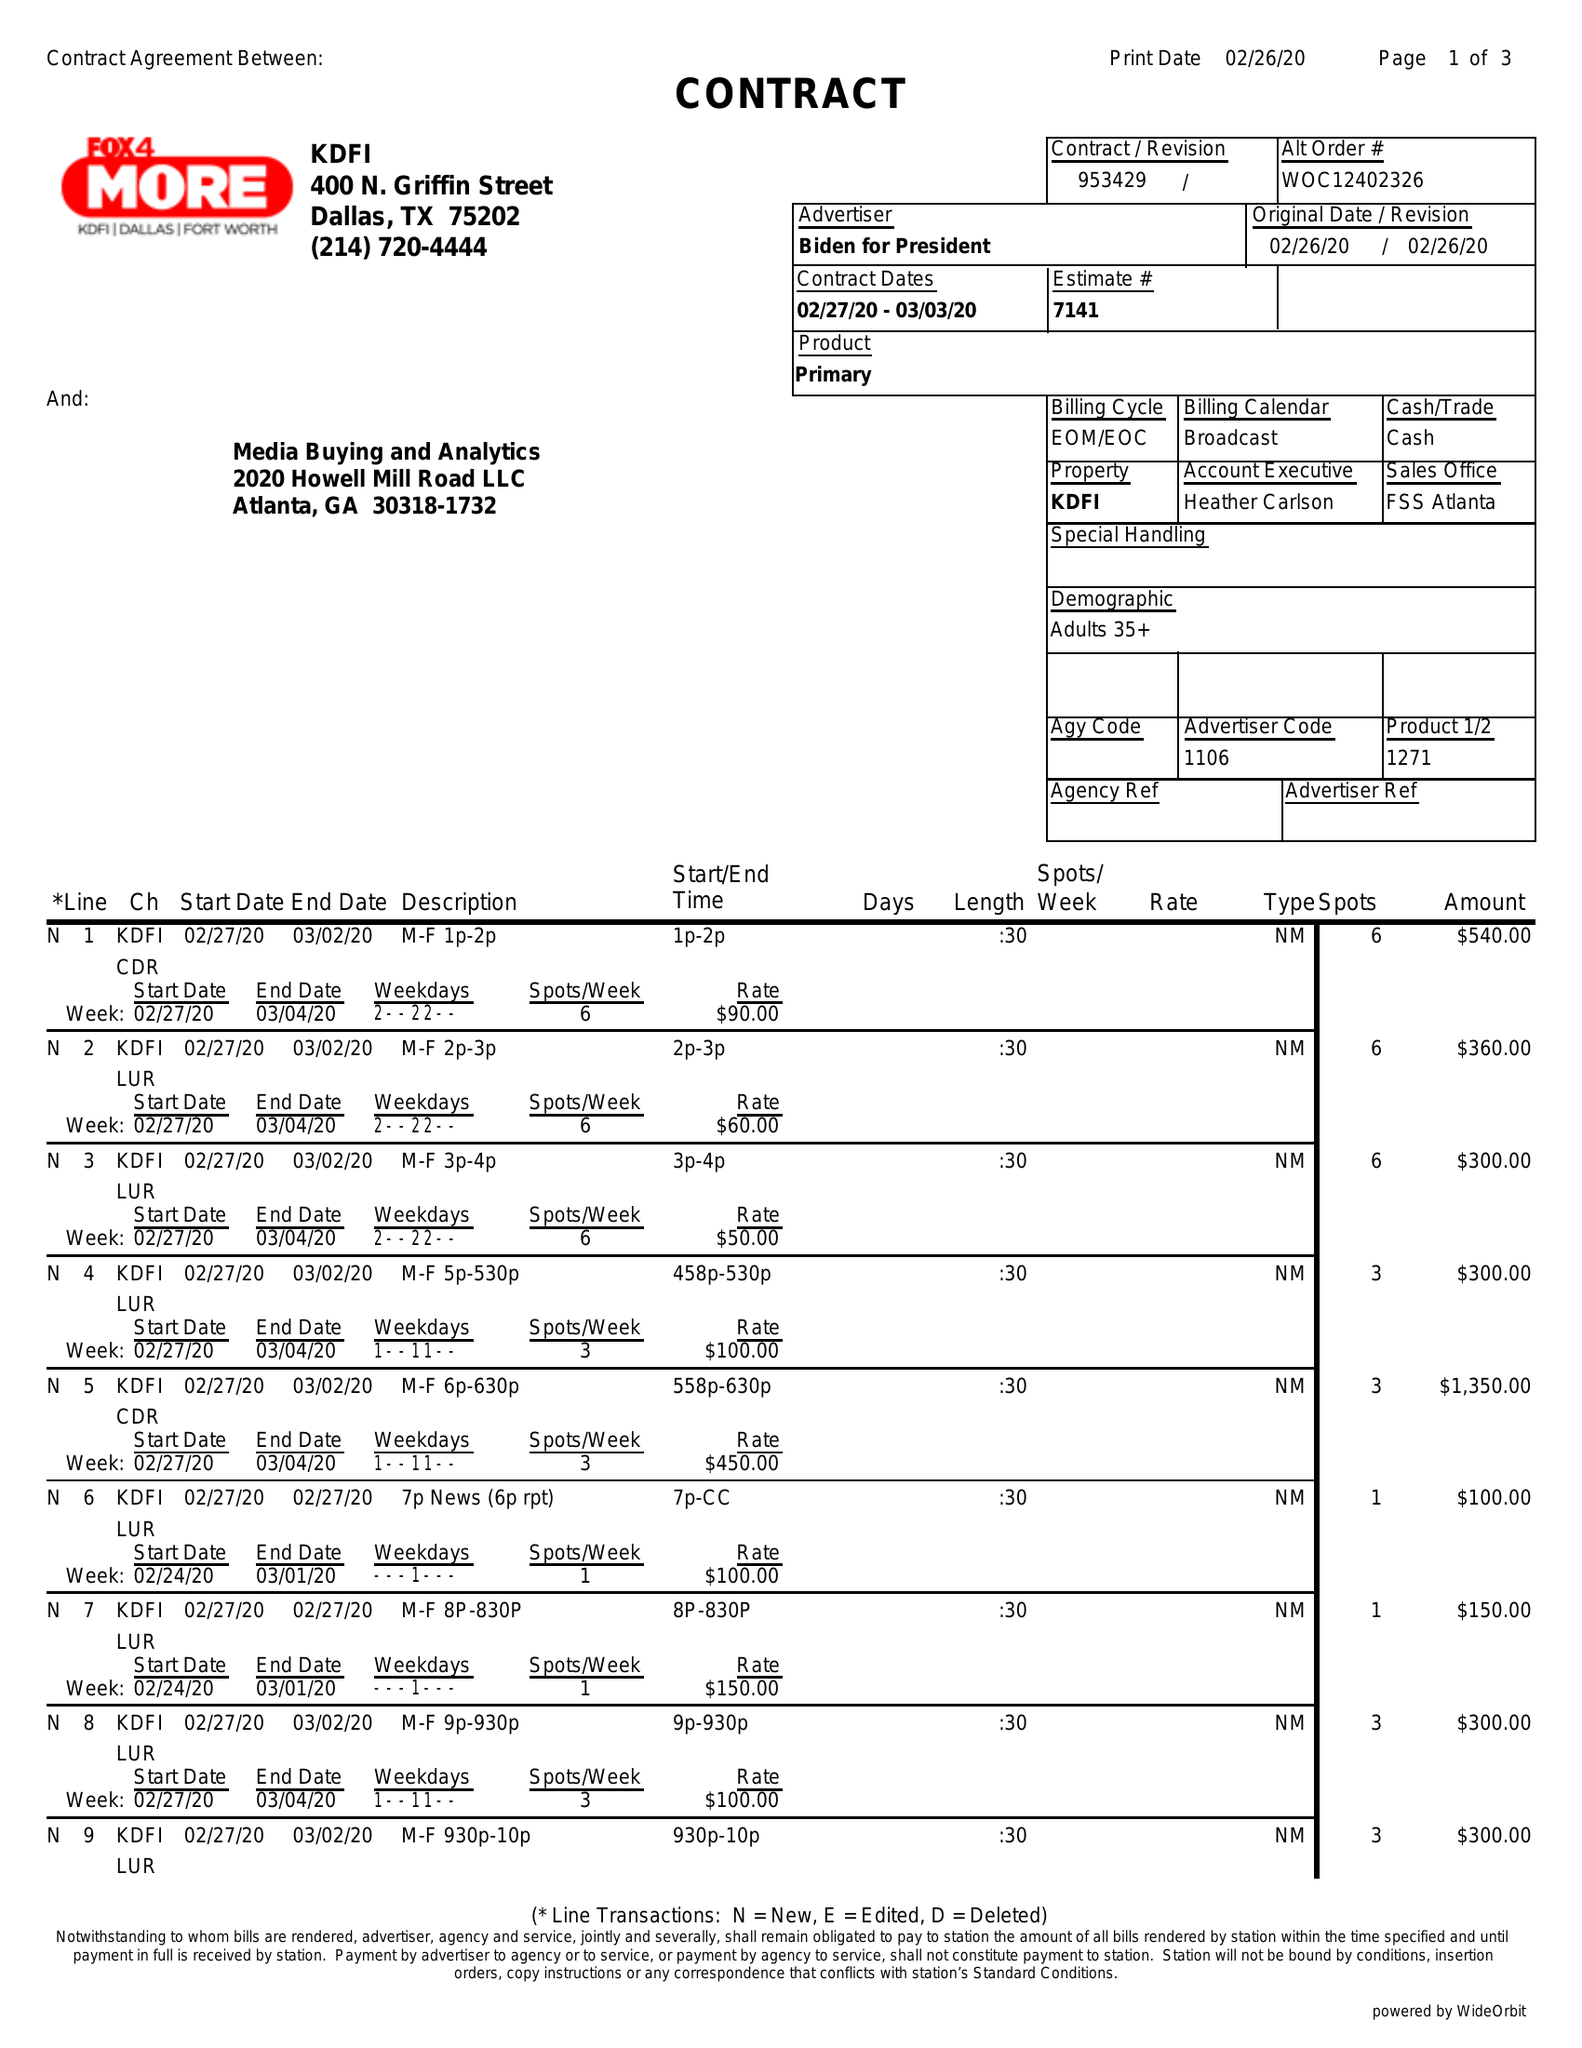What is the value for the gross_amount?
Answer the question using a single word or phrase. 3910.00 